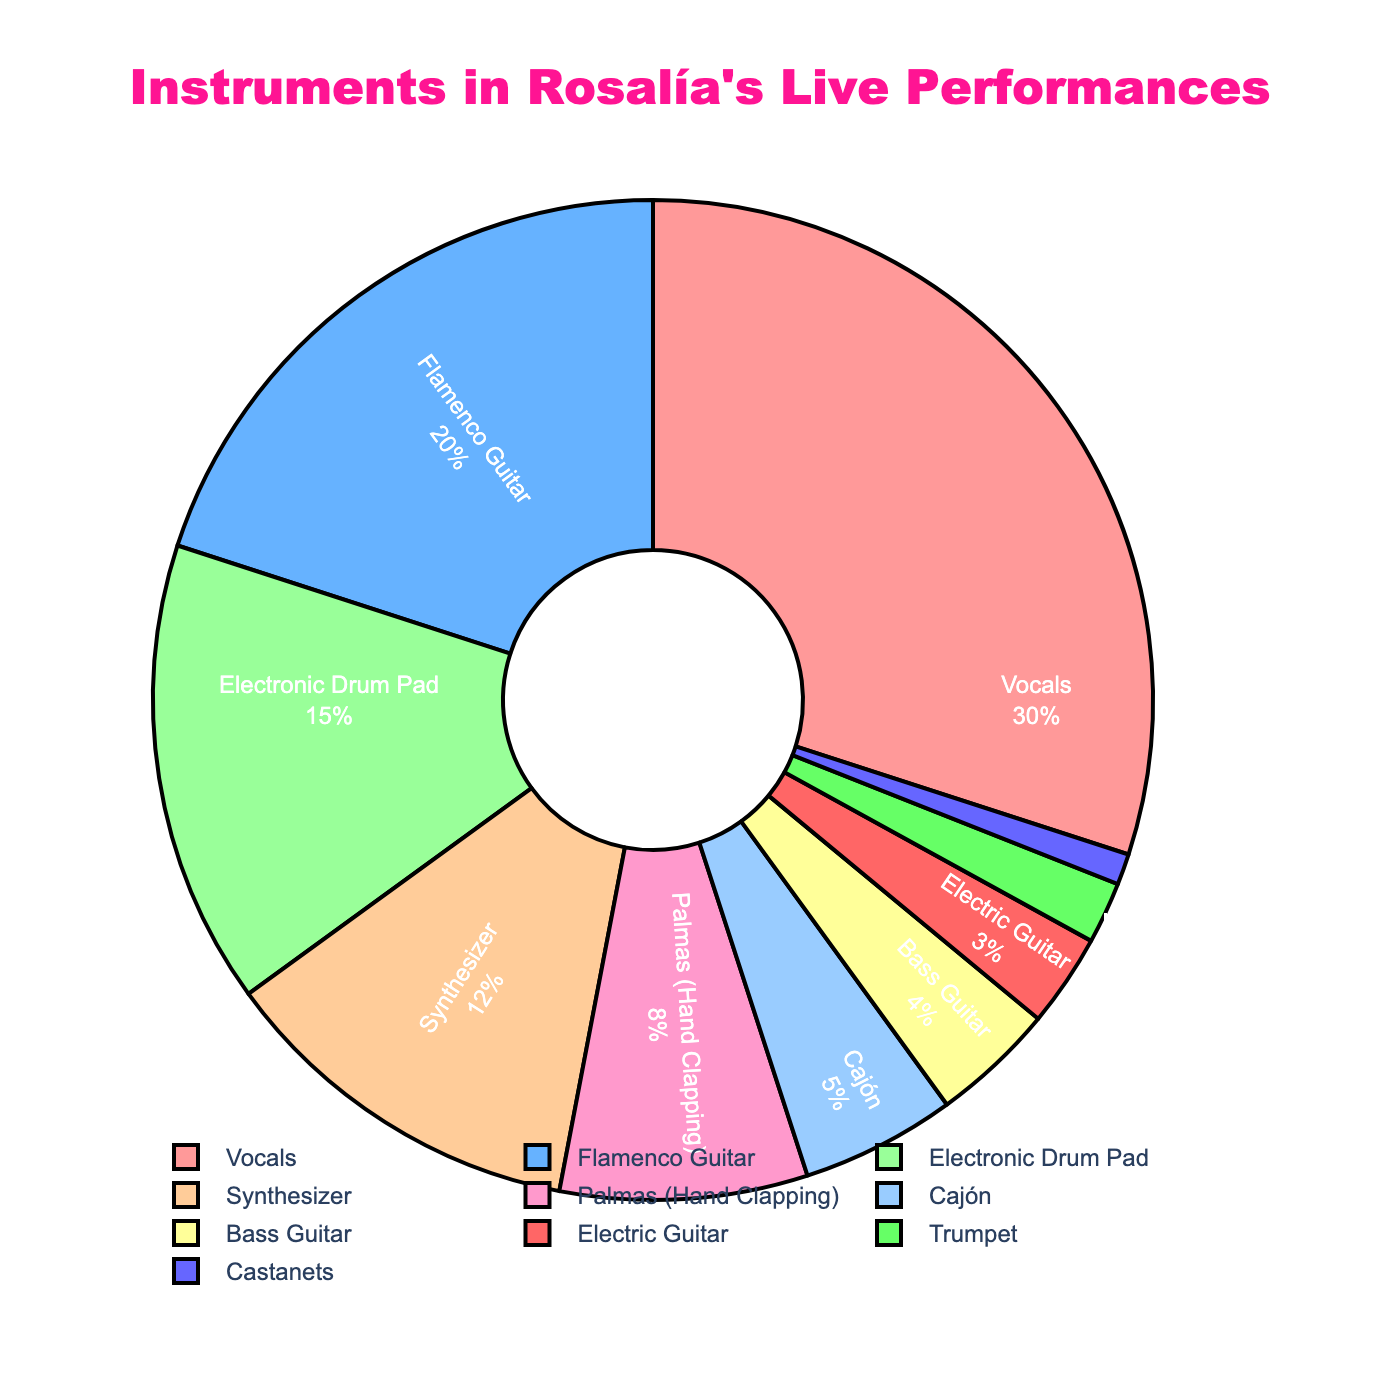What percentage of Rosalía's live performance instruments are electronic (like the synthesizer and electronic drum pad)? Add the percentages of the electronic drum pad and synthesizer. Electronic Drum Pad: 15% + Synthesizer: 12% = 27%
Answer: 27% Which instrument has the highest percentage in Rosalía's live performances? The figure shows the percentage breakdown of each instrument, and the segment labeled "Vocals" occupies the largest portion.
Answer: Vocals How much more frequently are vocals featured compared to the flamenco guitar? Subtract the percentage of Flamenco Guitar from the percentage of Vocals. Vocals: 30% - Flamenco Guitar: 20% = 10%
Answer: 10% What is the combined percentage of traditional flamenco instruments (flamenco guitar, palmas, cajón, and castanets)? Add the percentages of Flamenco Guitar, Palmas (Hand Clapping), Cajón, and Castanets. Flamenco Guitar: 20% + Palmas: 8% + Cajón: 5% + Castanets: 1% = 34%
Answer: 34% Which instrument is used the least in Rosalía's live performances? The figure shows that "Castanets" has the smallest segment, indicating it is used the least.
Answer: Castanets What visual attribute helps you identify the Vocals segment in the pie chart? The Vocals segment is identifiable by being the largest portion in the pie chart.
Answer: Largest segment Compare the use of electronic instruments (synthesizer and electronic drum pad) to traditional instruments (flamenco guitar, palmas, cajón, and castanets). Which category is more prevalent? Calculate the combined percentages for both categories and compare. Traditional Instruments: 20% (Flamenco Guitar) + 8% (Palmas) + 5% (Cajón) + 1% (Castanets) = 34%. Electronic Instruments: 15% (Electronic Drum Pad) + 12% (Synthesizer) = 27%. Traditional instruments are more prevalent by 34% - 27% = 7%
Answer: Traditional instruments by 7% What is the percentage difference between the use of bass guitar and electric guitar? Subtract the percentage of Electric Guitar from the percentage of Bass Guitar. Bass Guitar: 4% - Electric Guitar: 3% = 1%
Answer: 1% What colors are used to represent the synthesizer and the electronic drum pad segments in the pie chart? The synthesizer segment is represented in one of the vivid colors, like a bright green or blue, while the electronic drum pad segment is another distinct color.
Answer: Synthesizer: bright green or blue, Electronic Drum Pad: another distinct color Is the use of brass instruments like the trumpet more or less common than the use of bass guitar in Rosalía's performances? Compare the percentages of Trumpet and Bass Guitar. Trumpet: 2%, Bass Guitar: 4%. The bass guitar is more common.
Answer: Less common 